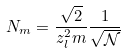Convert formula to latex. <formula><loc_0><loc_0><loc_500><loc_500>N _ { m } = \frac { \sqrt { 2 } } { z _ { l } ^ { 2 } m } \frac { 1 } { \sqrt { \mathcal { N } } }</formula> 